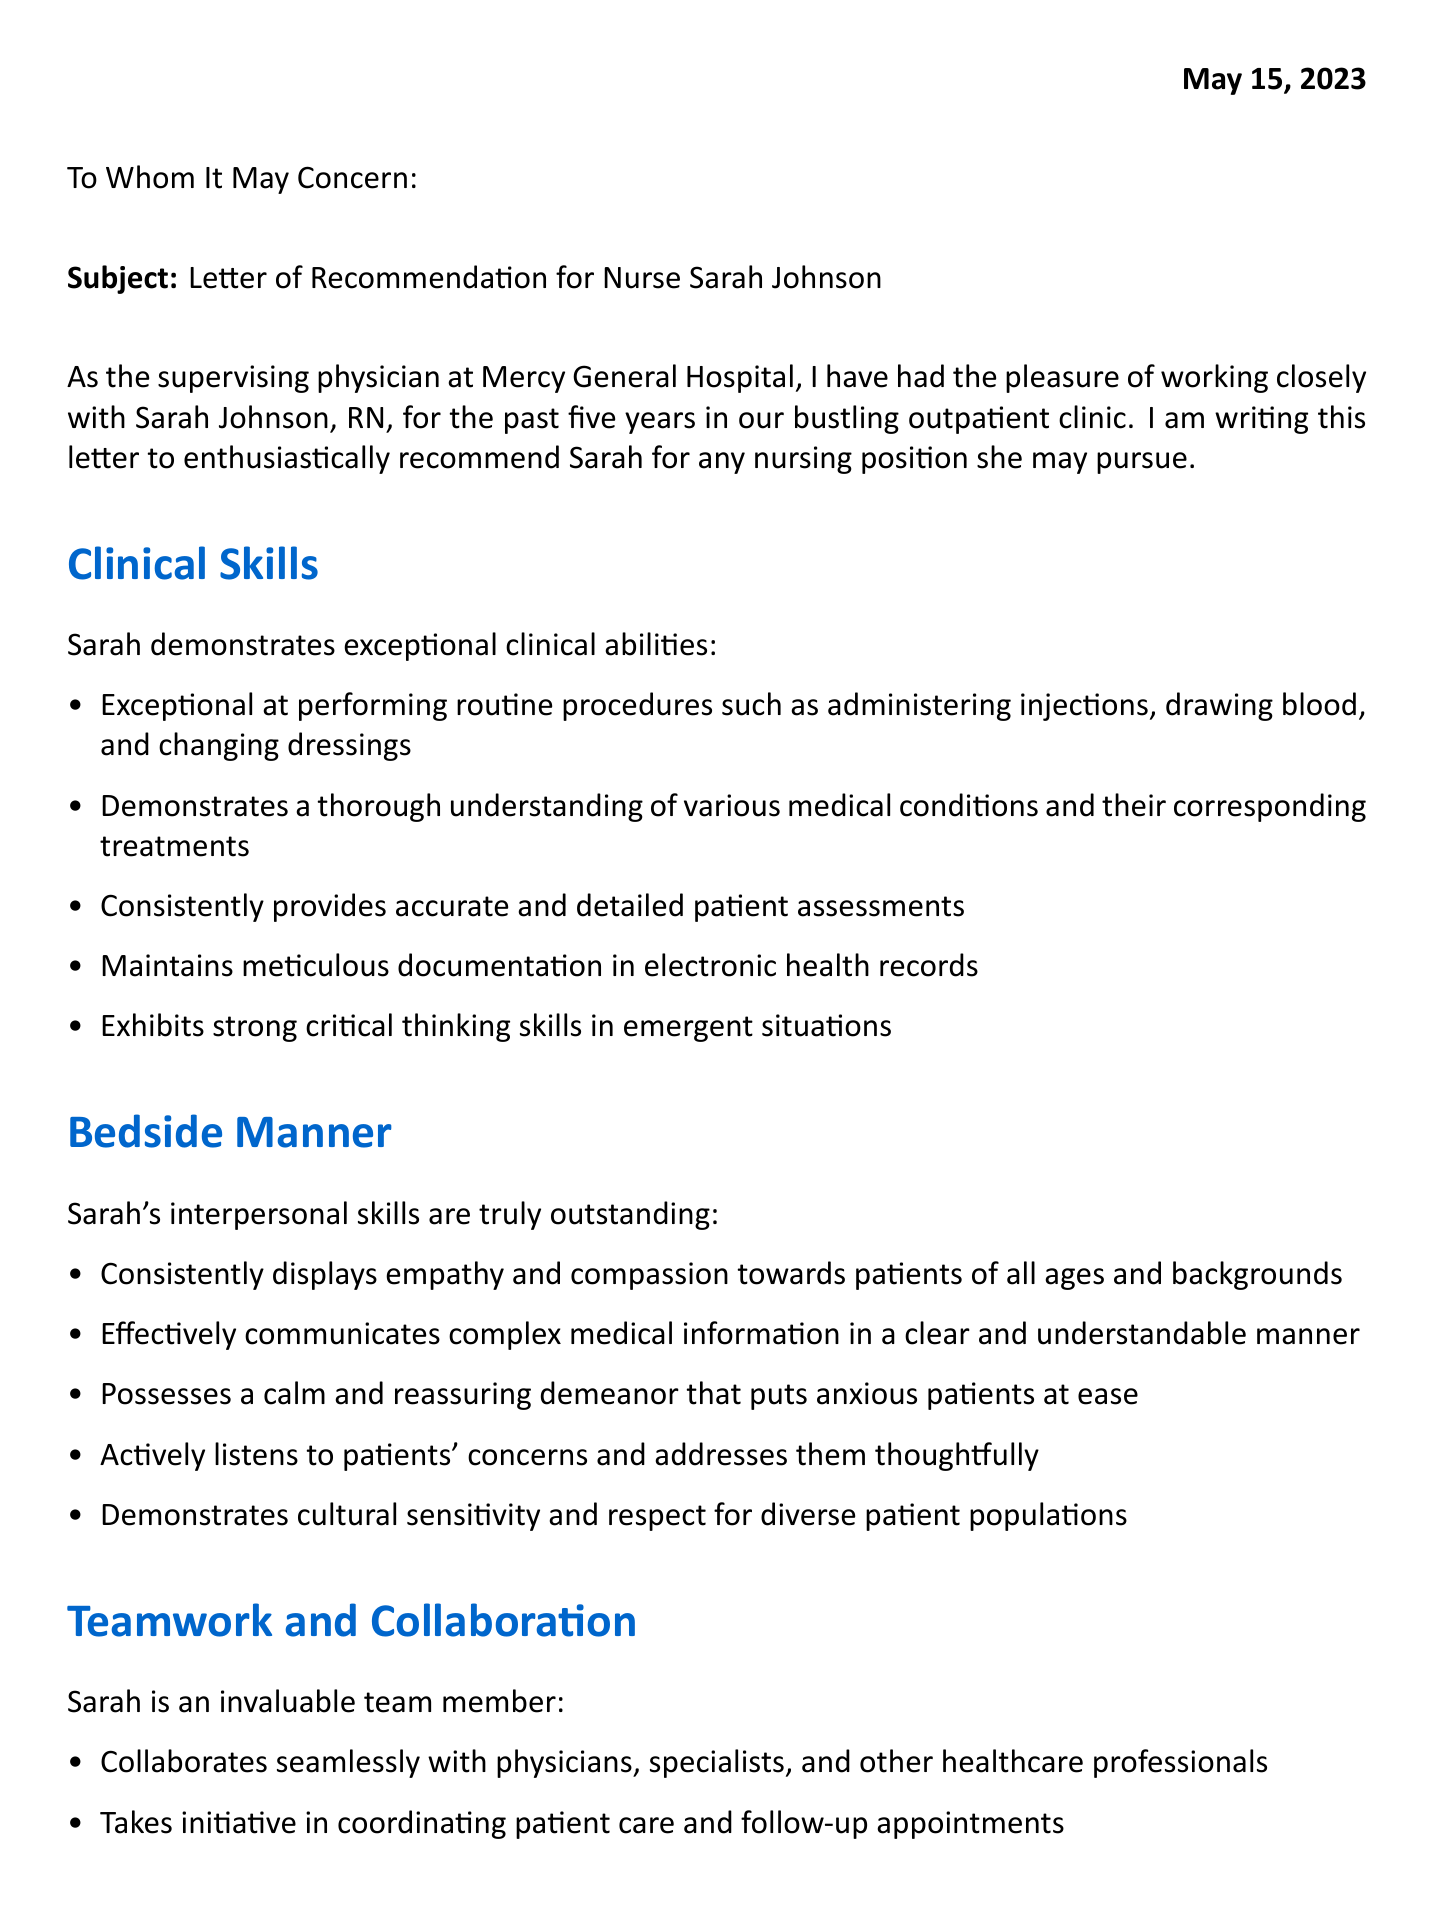What is the date of the letter? The date is clearly stated at the beginning of the letter, marking when it was written.
Answer: May 15, 2023 Who is the addressee of the letter? The letter begins with an address line that specifies who the intended recipient is.
Answer: To Whom It May Concern Who wrote the letter? The signature section of the letter identifies the author of the recommendation.
Answer: Dr. Michael Williams, MD What position does Sarah Johnson hold? The introduction in the letter indicates the professional title of the individual being recommended.
Answer: RN What specific skill is highlighted under "Clinical Skills"? The letter lists multiple skills, focusing on one that can be distinctly identified.
Answer: Administering injections In what setting has the physician worked with Sarah Johnson? The document describes the environment where the working relationship took place.
Answer: Outpatient clinic What initiative has Sarah recently completed? The professional development section mentions a recent educational achievement.
Answer: Certification in wound care management What characteristic is mentioned regarding Sarah's bedside manner? The letter emphasizes a key attribute of her patient interaction style.
Answer: Empathy and compassion How does Sarah contribute to teamwork? The letter includes a section that discusses her role within the healthcare team dynamics.
Answer: Mentors new nurses 